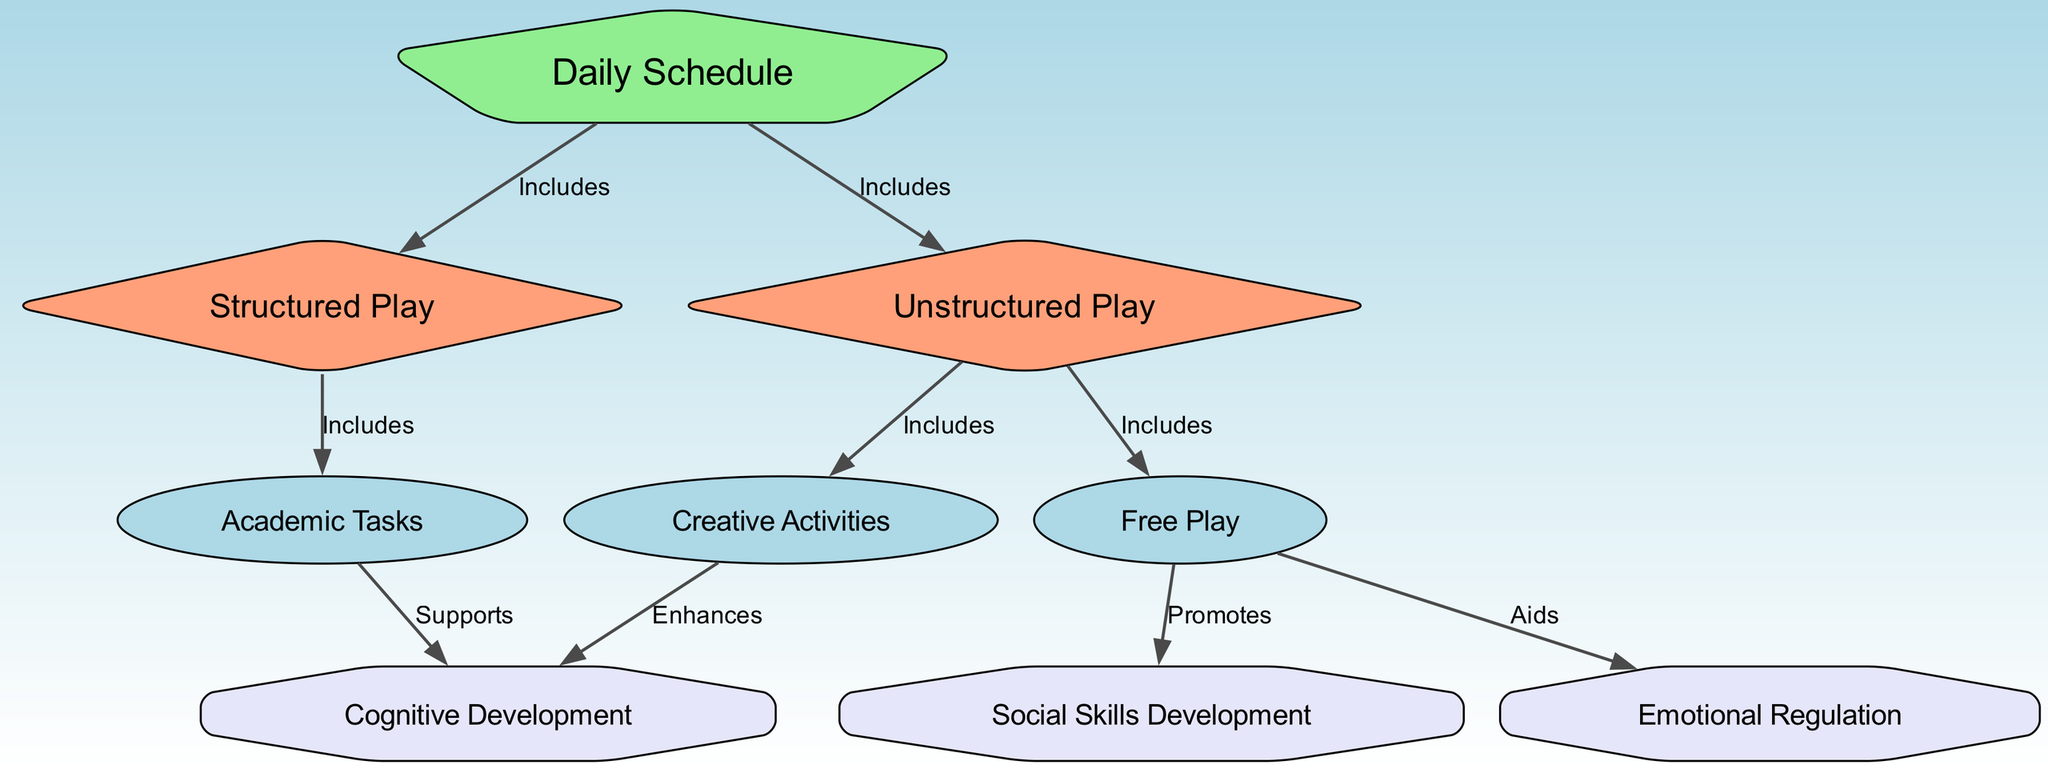What are the two types of play included in the Daily Schedule? The diagram clearly shows two types of play that are included under the Daily Schedule node: Structured Play and Unstructured Play.
Answer: Structured Play, Unstructured Play Which node mentions Cognitive Development? Looking at the edges from the nodes, the Academic Tasks node is linked to the Cognitive Development node with a support relationship, indicating that it mentions Cognitive Development.
Answer: Academic Tasks How many total nodes are present in the diagram? By counting the nodes listed in the diagram, there are a total of nine nodes which represent different aspects of the daily schedule and its outcomes.
Answer: Nine What does Free Play promote according to the diagram? The diagram specifies that Free Play is linked to Social Skills Development, indicating that it promotes this outcome.
Answer: Social Skills Development What enhances Cognitive Development according to the diagram? The diagram establishes a connection where Creative Activities enhances Cognitive Development, indicating that this is the activity that has a positive effect on cognitive skills.
Answer: Creative Activities Which type of play includes Academic Tasks? The diagram clearly indicates that Structured Play includes Academic Tasks, establishing a direct relationship between the two.
Answer: Structured Play How many edges are involved in this diagram? By reviewing the connections listed in the diagram, there are a total of eight edges that depict the relationships between nodes.
Answer: Eight Which two concepts are directly linked to Emotional Regulation? Examining the diagram, we find that Free Play and Emotional Regulation are connected, highlighting that Free Play aids in Emotional Regulation.
Answer: Free Play What kind of activities fall under Unstructured Play? The diagram indicates that Unstructured Play falls under Free Play and Creative Activities, elaborating on the inclusive nature of unstructured play activities.
Answer: Free Play, Creative Activities 